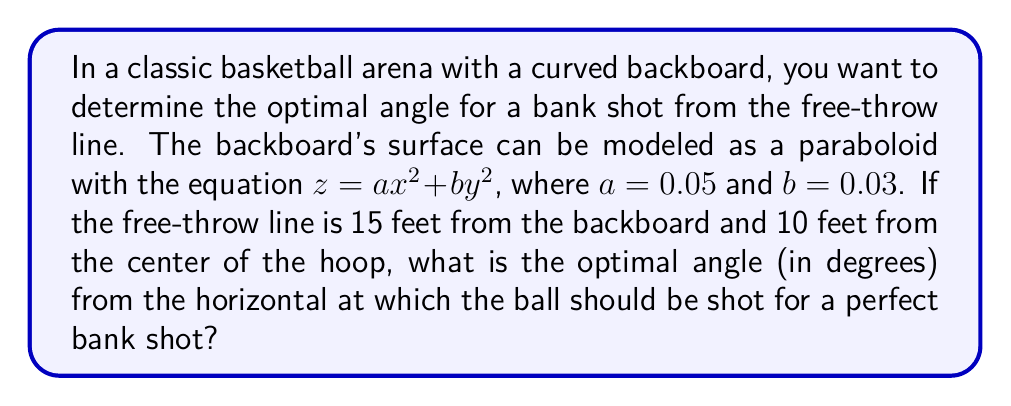Can you answer this question? Let's approach this step-by-step:

1) First, we need to understand that the optimal angle for a bank shot is one where the ball's trajectory is perpendicular to the backboard's surface at the point of contact.

2) The gradient of the surface at any point gives us the normal vector to the surface at that point. For our paraboloid $z = ax^2 + by^2$, the gradient is:

   $$\nabla z = (2ax, 2by, -1)$$

3) The point of contact on the backboard should be directly above the center of the hoop. If the hoop is 10 feet from the backboard, this point will be at $(0, 0, 10)$.

4) Substituting this point into our gradient:

   $$\nabla z = (0, 0, -1)$$

5) Now, we need to find the vector from the free-throw line to this point on the backboard. The free-throw line is 15 feet from the backboard, so the vector is:

   $$\vec{v} = (0, 0, 10) - (15, 0, 0) = (-15, 0, 10)$$

6) The optimal angle will be the angle between this vector and the horizontal plane. We can find this using the dot product of our vector with the unit vector in the x-direction:

   $$\cos \theta = \frac{\vec{v} \cdot (1, 0, 0)}{|\vec{v}|} = \frac{-15}{\sqrt{15^2 + 10^2}}$$

7) Taking the inverse cosine and converting to degrees:

   $$\theta = \arccos\left(\frac{-15}{\sqrt{15^2 + 10^2}}\right) \cdot \frac{180}{\pi} \approx 146.31^\circ$$

8) However, we typically measure this angle from the horizontal upwards, so we need to subtract from 180°:

   $$180^\circ - 146.31^\circ = 33.69^\circ$$
Answer: $33.69^\circ$ 